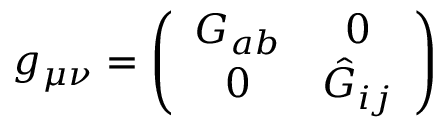Convert formula to latex. <formula><loc_0><loc_0><loc_500><loc_500>g _ { \mu \nu } = \left ( \begin{array} { c c } { { G _ { a b } } } & { 0 } \\ { 0 } & { { \hat { G } _ { i j } } } \end{array} \right )</formula> 